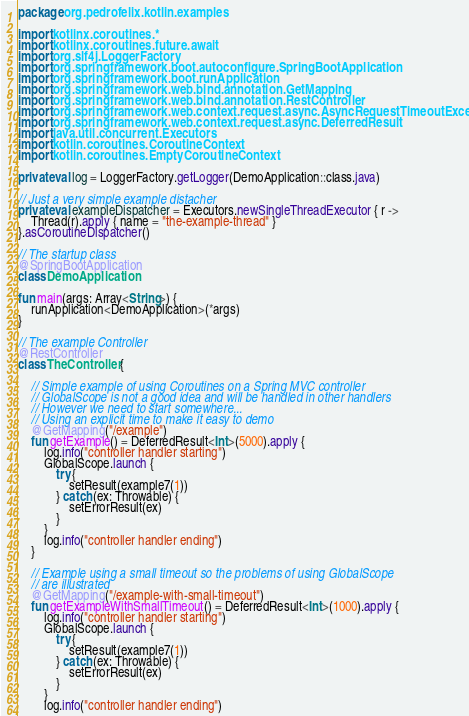Convert code to text. <code><loc_0><loc_0><loc_500><loc_500><_Kotlin_>package org.pedrofelix.kotlin.examples

import kotlinx.coroutines.*
import kotlinx.coroutines.future.await
import org.slf4j.LoggerFactory
import org.springframework.boot.autoconfigure.SpringBootApplication
import org.springframework.boot.runApplication
import org.springframework.web.bind.annotation.GetMapping
import org.springframework.web.bind.annotation.RestController
import org.springframework.web.context.request.async.AsyncRequestTimeoutException
import org.springframework.web.context.request.async.DeferredResult
import java.util.concurrent.Executors
import kotlin.coroutines.CoroutineContext
import kotlin.coroutines.EmptyCoroutineContext

private val log = LoggerFactory.getLogger(DemoApplication::class.java)

// Just a very simple example distacher
private val exampleDispatcher = Executors.newSingleThreadExecutor { r ->
    Thread(r).apply { name = "the-example-thread" }
}.asCoroutineDispatcher()

// The startup class
@SpringBootApplication
class DemoApplication

fun main(args: Array<String>) {
    runApplication<DemoApplication>(*args)
}

// The example Controller
@RestController
class TheController {

    // Simple example of using Coroutines on a Spring MVC controller
    // GlobalScope is not a good idea and will be handled in other handlers
    // However we need to start somewhere...
    // Using an explicit time to make it easy to demo
    @GetMapping("/example")
    fun getExample() = DeferredResult<Int>(5000).apply {
        log.info("controller handler starting")
        GlobalScope.launch {
            try {
                setResult(example7(1))
            } catch (ex: Throwable) {
                setErrorResult(ex)
            }
        }
        log.info("controller handler ending")
    }

    // Example using a small timeout so the problems of using GlobalScope
    // are illustrated
    @GetMapping("/example-with-small-timeout")
    fun getExampleWithSmallTimeout() = DeferredResult<Int>(1000).apply {
        log.info("controller handler starting")
        GlobalScope.launch {
            try {
                setResult(example7(1))
            } catch (ex: Throwable) {
                setErrorResult(ex)
            }
        }
        log.info("controller handler ending")</code> 